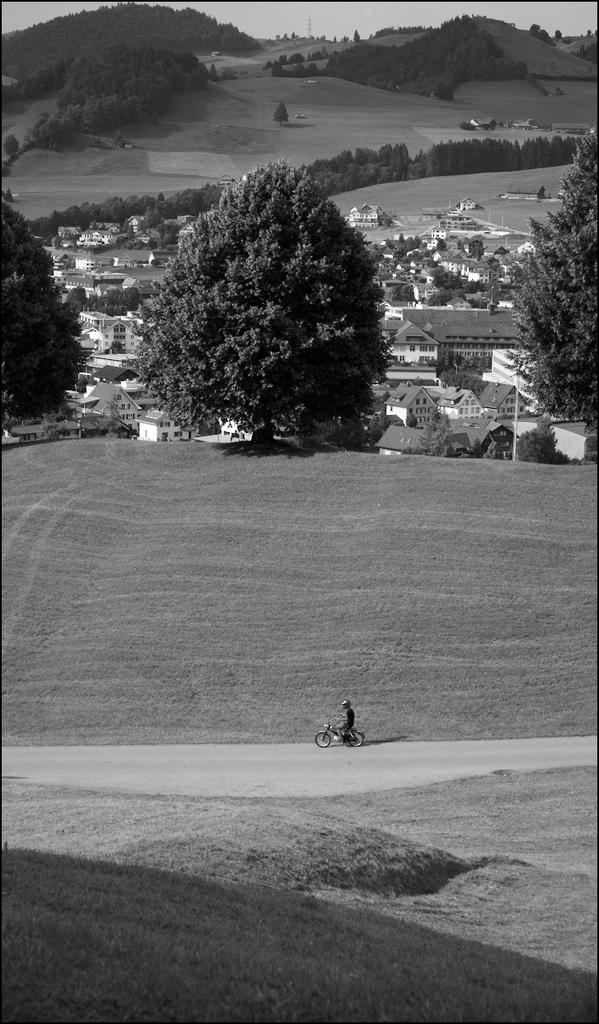What is the color scheme of the image? The image is in black and white. What is the main subject of the image? The image depicts a city. Can you describe the person in the image? There is a person with a motorbike in the image. What can be seen in the background of the image? There are trees, houses, hills, and the sky visible in the background of the image. Where is the quicksand located in the image? There is no quicksand present in the image. What type of furniture can be seen in the image? There is no furniture present in the image. 